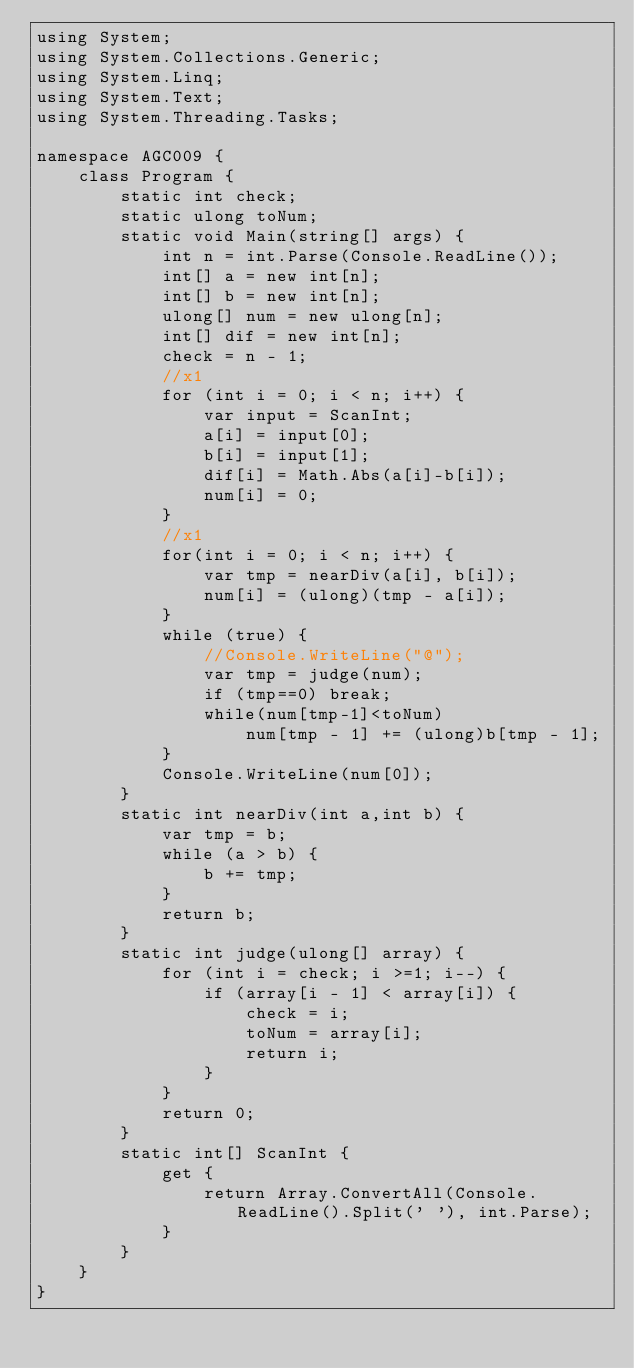<code> <loc_0><loc_0><loc_500><loc_500><_C#_>using System;
using System.Collections.Generic;
using System.Linq;
using System.Text;
using System.Threading.Tasks;

namespace AGC009 {
    class Program {
        static int check;
        static ulong toNum;
        static void Main(string[] args) {
            int n = int.Parse(Console.ReadLine());
            int[] a = new int[n];
            int[] b = new int[n];
            ulong[] num = new ulong[n];
            int[] dif = new int[n];
            check = n - 1;
            //x1
            for (int i = 0; i < n; i++) {
                var input = ScanInt;
                a[i] = input[0];
                b[i] = input[1];
                dif[i] = Math.Abs(a[i]-b[i]);
                num[i] = 0;
            }
            //x1
            for(int i = 0; i < n; i++) {
                var tmp = nearDiv(a[i], b[i]);
                num[i] = (ulong)(tmp - a[i]);
            }
            while (true) {
                //Console.WriteLine("@");
                var tmp = judge(num);
                if (tmp==0) break;
                while(num[tmp-1]<toNum)
                    num[tmp - 1] += (ulong)b[tmp - 1];
            }
            Console.WriteLine(num[0]);
        }
        static int nearDiv(int a,int b) {
            var tmp = b;
            while (a > b) {
                b += tmp;
            }
            return b;
        }
        static int judge(ulong[] array) {
            for (int i = check; i >=1; i--) {
                if (array[i - 1] < array[i]) {
                    check = i;
                    toNum = array[i];
                    return i;
                }
            }
            return 0;
        }
        static int[] ScanInt {
            get {
                return Array.ConvertAll(Console.ReadLine().Split(' '), int.Parse);
            }
        }
    }
}
</code> 